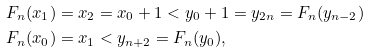Convert formula to latex. <formula><loc_0><loc_0><loc_500><loc_500>& F _ { n } ( x _ { 1 } ) = x _ { 2 } = x _ { 0 } + 1 < y _ { 0 } + 1 = y _ { 2 n } = F _ { n } ( y _ { n - 2 } ) \\ & F _ { n } ( x _ { 0 } ) = x _ { 1 } < y _ { n + 2 } = F _ { n } ( y _ { 0 } ) ,</formula> 